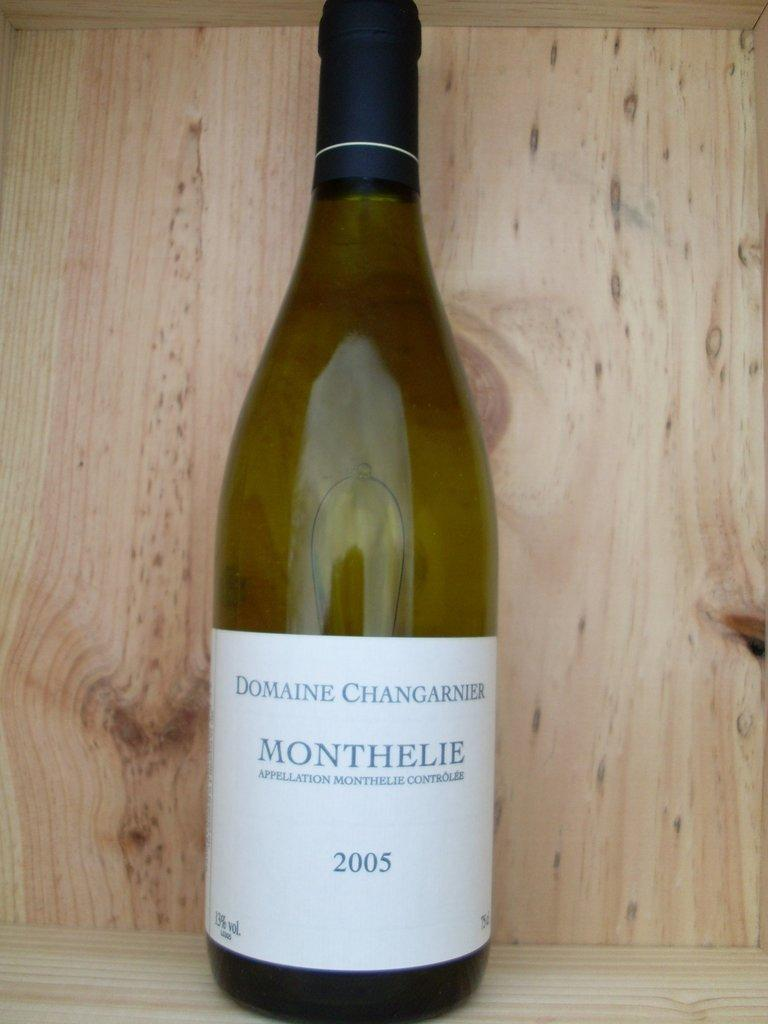<image>
Present a compact description of the photo's key features. A bottle has the year 2005 and the brand name Monthelie. 